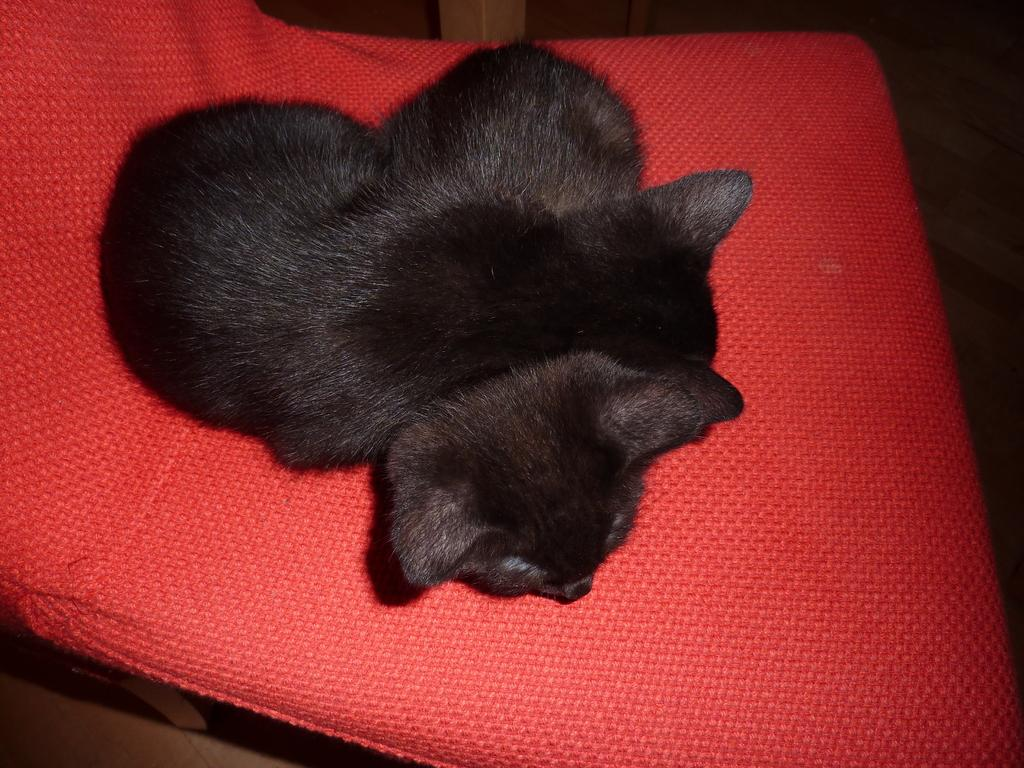How many animals are present in the image? There are two animals in the image. What are the animals doing in the image? The animals are sitting on a red color chair. Can you describe any other objects visible in the background of the image? Unfortunately, the provided facts do not give any information about the objects in the background. What type of crayon is the animal holding in the image? There is no crayon present in the image. Can you describe the house where the animals are sitting in the image? There is no house present in the image; the animals are sitting on a red color chair. 